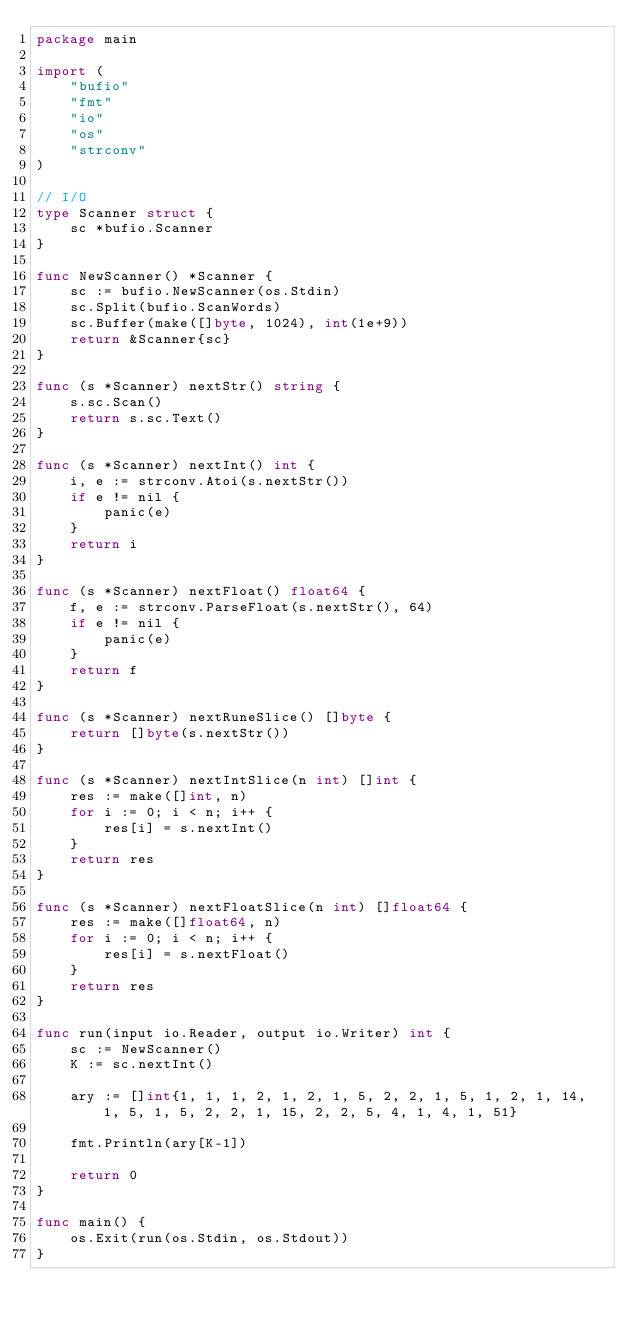<code> <loc_0><loc_0><loc_500><loc_500><_Go_>package main

import (
	"bufio"
	"fmt"
	"io"
	"os"
	"strconv"
)

// I/O
type Scanner struct {
	sc *bufio.Scanner
}

func NewScanner() *Scanner {
	sc := bufio.NewScanner(os.Stdin)
	sc.Split(bufio.ScanWords)
	sc.Buffer(make([]byte, 1024), int(1e+9))
	return &Scanner{sc}
}

func (s *Scanner) nextStr() string {
	s.sc.Scan()
	return s.sc.Text()
}

func (s *Scanner) nextInt() int {
	i, e := strconv.Atoi(s.nextStr())
	if e != nil {
		panic(e)
	}
	return i
}

func (s *Scanner) nextFloat() float64 {
	f, e := strconv.ParseFloat(s.nextStr(), 64)
	if e != nil {
		panic(e)
	}
	return f
}

func (s *Scanner) nextRuneSlice() []byte {
	return []byte(s.nextStr())
}

func (s *Scanner) nextIntSlice(n int) []int {
	res := make([]int, n)
	for i := 0; i < n; i++ {
		res[i] = s.nextInt()
	}
	return res
}

func (s *Scanner) nextFloatSlice(n int) []float64 {
	res := make([]float64, n)
	for i := 0; i < n; i++ {
		res[i] = s.nextFloat()
	}
	return res
}

func run(input io.Reader, output io.Writer) int {
	sc := NewScanner()
	K := sc.nextInt()

	ary := []int{1, 1, 1, 2, 1, 2, 1, 5, 2, 2, 1, 5, 1, 2, 1, 14, 1, 5, 1, 5, 2, 2, 1, 15, 2, 2, 5, 4, 1, 4, 1, 51}

	fmt.Println(ary[K-1])

	return 0
}

func main() {
	os.Exit(run(os.Stdin, os.Stdout))
}
</code> 